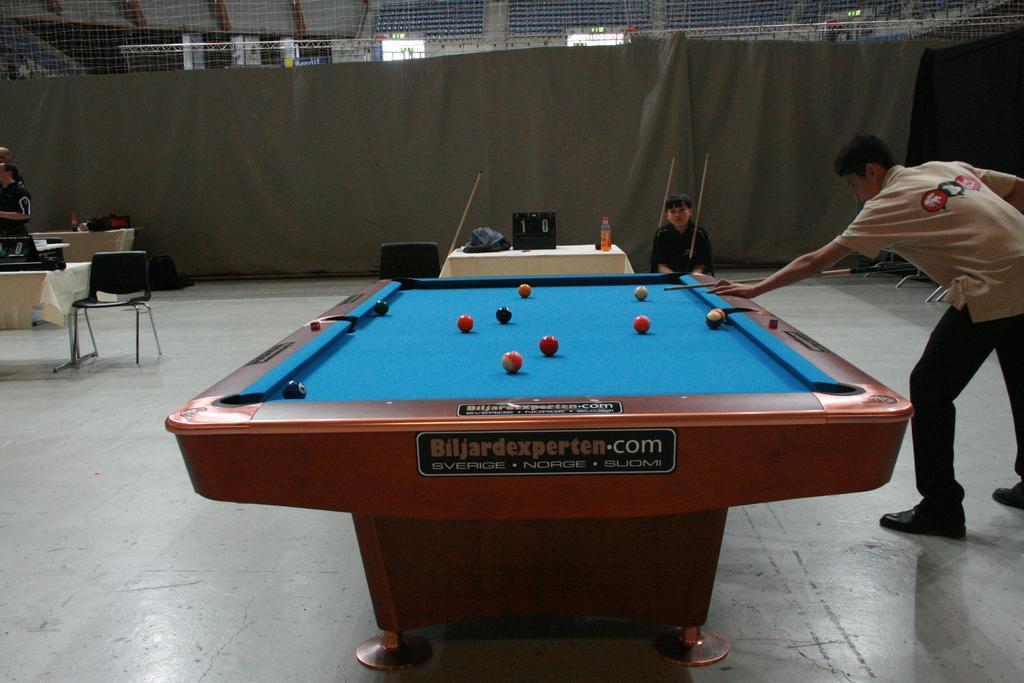Could you give a brief overview of what you see in this image? In this picture I can see there is a snooker table and there is a man playing the snooker here and he is holding a stick in his hand and in the backdrop I can see there is another person sitting and holding the snooker stick. There are some other people in the backdrop and there is a grey curtain. 